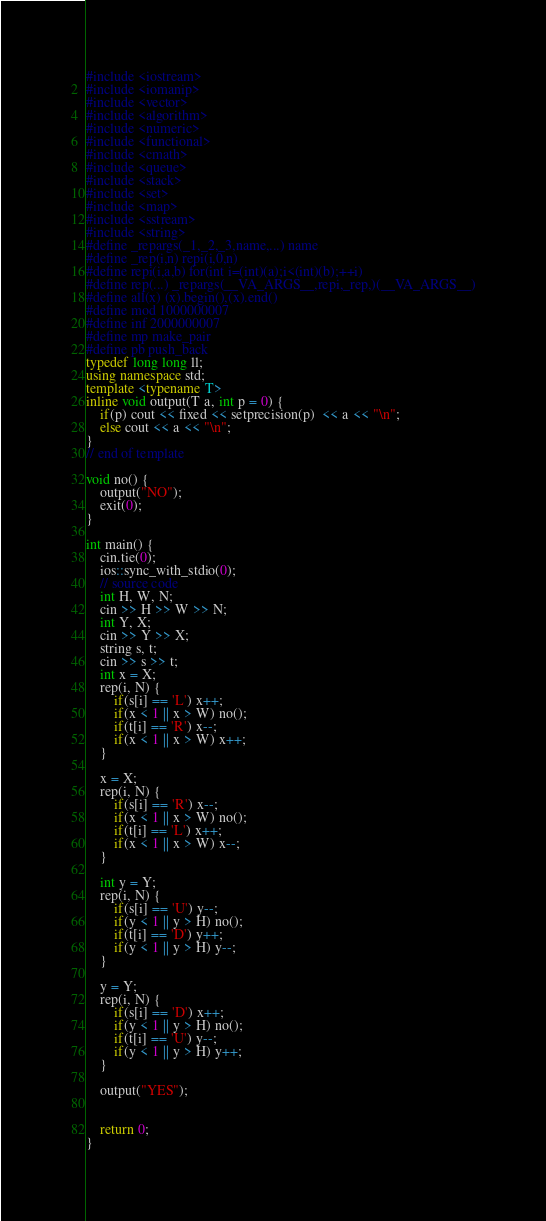Convert code to text. <code><loc_0><loc_0><loc_500><loc_500><_C++_>#include <iostream>
#include <iomanip>
#include <vector>
#include <algorithm>
#include <numeric>
#include <functional>
#include <cmath>
#include <queue>
#include <stack>
#include <set>
#include <map>
#include <sstream>
#include <string>
#define _repargs(_1,_2,_3,name,...) name
#define _rep(i,n) repi(i,0,n)
#define repi(i,a,b) for(int i=(int)(a);i<(int)(b);++i)
#define rep(...) _repargs(__VA_ARGS__,repi,_rep,)(__VA_ARGS__)
#define all(x) (x).begin(),(x).end()
#define mod 1000000007
#define inf 2000000007
#define mp make_pair
#define pb push_back
typedef long long ll;
using namespace std;
template <typename T>
inline void output(T a, int p = 0) {
    if(p) cout << fixed << setprecision(p)  << a << "\n";
    else cout << a << "\n";
}
// end of template

void no() {
    output("NO");
    exit(0);
}

int main() {
    cin.tie(0);
    ios::sync_with_stdio(0);
    // source code
    int H, W, N;
    cin >> H >> W >> N;
    int Y, X;
    cin >> Y >> X;
    string s, t;
    cin >> s >> t;
    int x = X;
    rep(i, N) {
        if(s[i] == 'L') x++;
        if(x < 1 || x > W) no();
        if(t[i] == 'R') x--;
        if(x < 1 || x > W) x++;
    }
    
    x = X;
    rep(i, N) {
        if(s[i] == 'R') x--;
        if(x < 1 || x > W) no();
        if(t[i] == 'L') x++;
        if(x < 1 || x > W) x--;
    }
    
    int y = Y;
    rep(i, N) {
        if(s[i] == 'U') y--;
        if(y < 1 || y > H) no();
        if(t[i] == 'D') y++;
        if(y < 1 || y > H) y--;
    }
    
    y = Y;
    rep(i, N) {
        if(s[i] == 'D') x++;
        if(y < 1 || y > H) no();
        if(t[i] == 'U') y--;
        if(y < 1 || y > H) y++;
    }
    
    output("YES");
   
    
    return 0;
}
</code> 